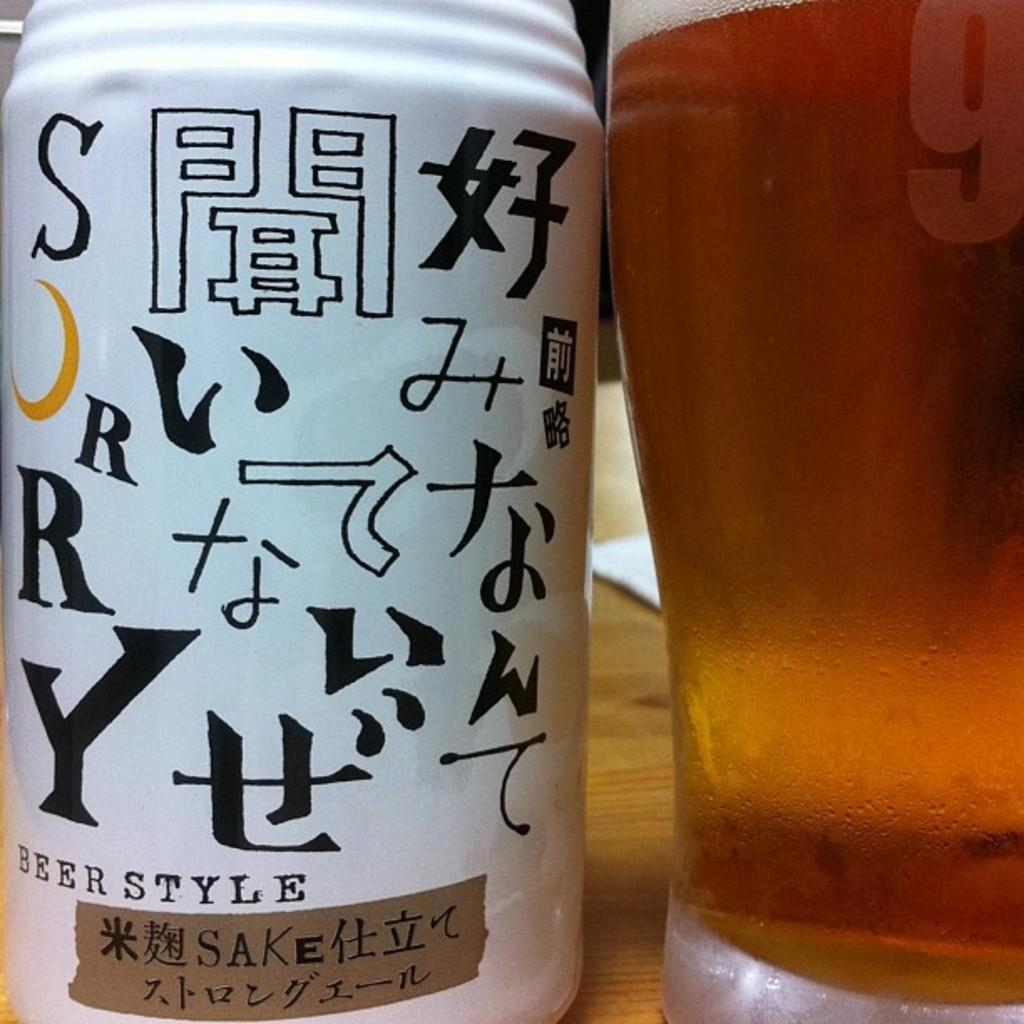What is placed on the wooden surface in the image? There is a glass on a wooden surface. What is inside the glass? There is a drink in the glass. What is located beside the glass? There is a bottle beside the glass. Can you describe the bottle? The bottle has symbols and text on it has text on it. What type of yam can be seen in the glass? There is no yam present in the image; the glass contains a drink. What is the taste of the fact in the image? There is no fact present in the image, and facts do not have a taste. 